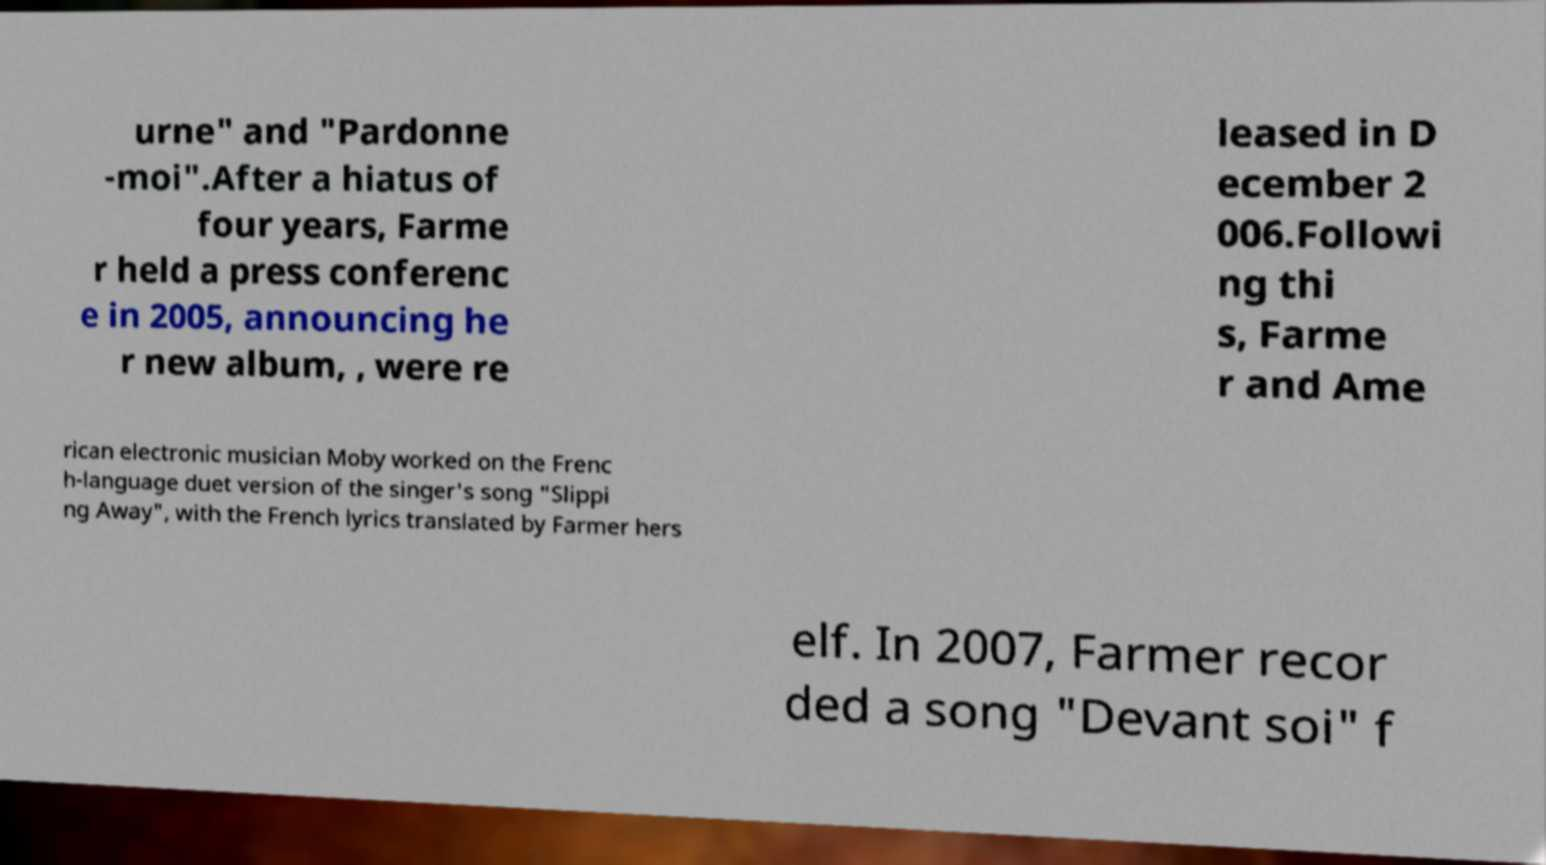For documentation purposes, I need the text within this image transcribed. Could you provide that? urne" and "Pardonne -moi".After a hiatus of four years, Farme r held a press conferenc e in 2005, announcing he r new album, , were re leased in D ecember 2 006.Followi ng thi s, Farme r and Ame rican electronic musician Moby worked on the Frenc h-language duet version of the singer's song "Slippi ng Away", with the French lyrics translated by Farmer hers elf. In 2007, Farmer recor ded a song "Devant soi" f 